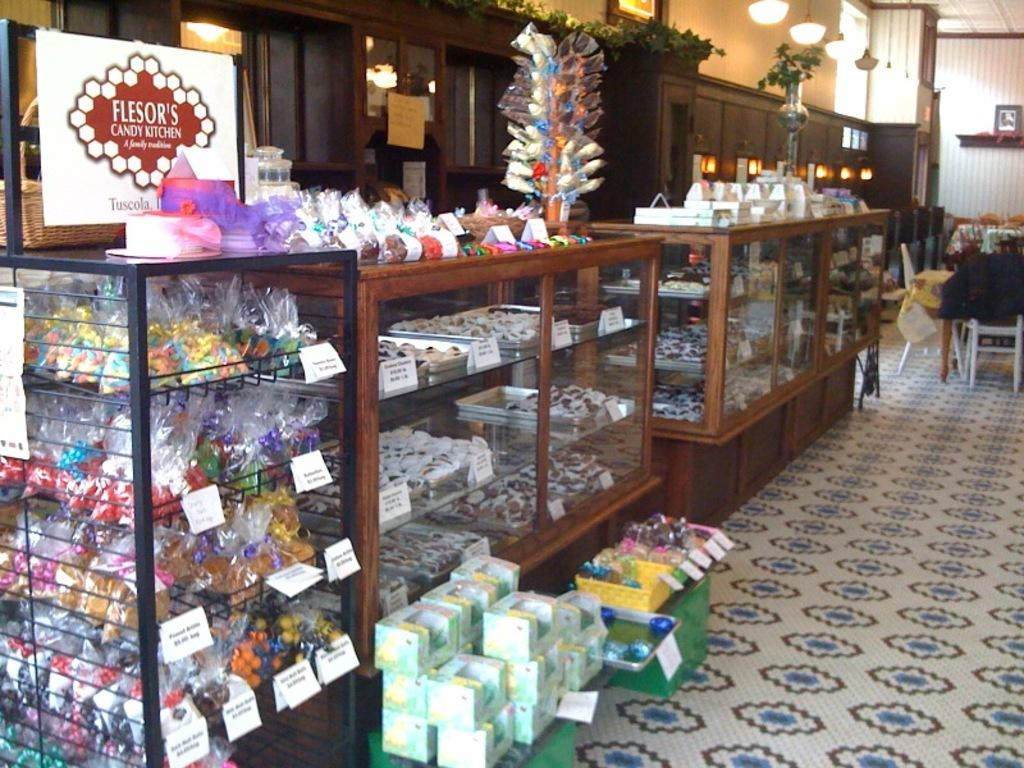<image>
Give a short and clear explanation of the subsequent image. The candy store shown is called Flesor's Candy Kitchen 